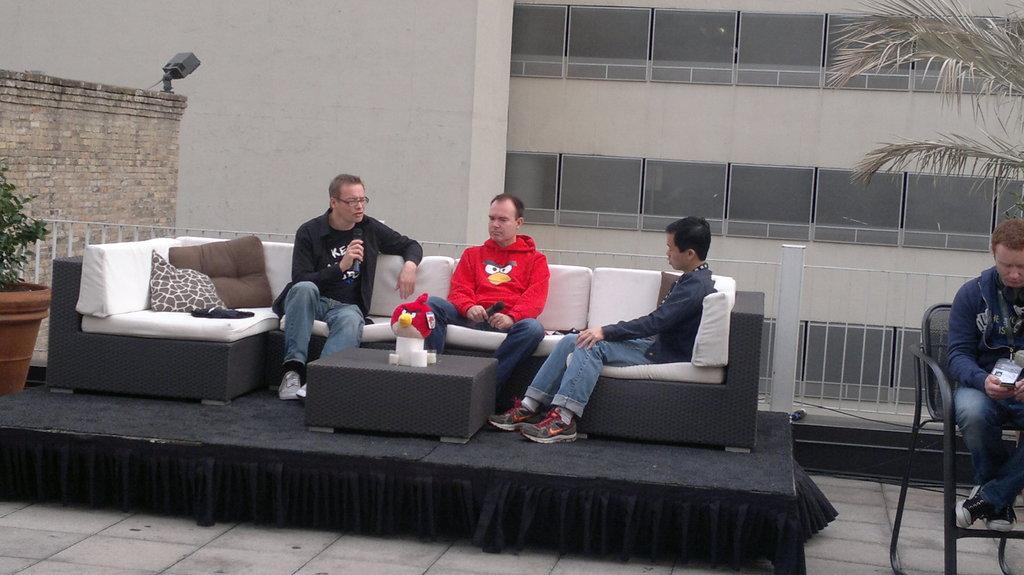How many people are sitting on the sofa in the image? There are three people sitting on the sofa in the image. What is the man in the image doing? The man is sitting on a chair in the image. What type of snails can be seen crawling on the jelly in the image? There are no snails or jelly present in the image. How many tomatoes are on the table in the image? There is no table or tomatoes present in the image. 